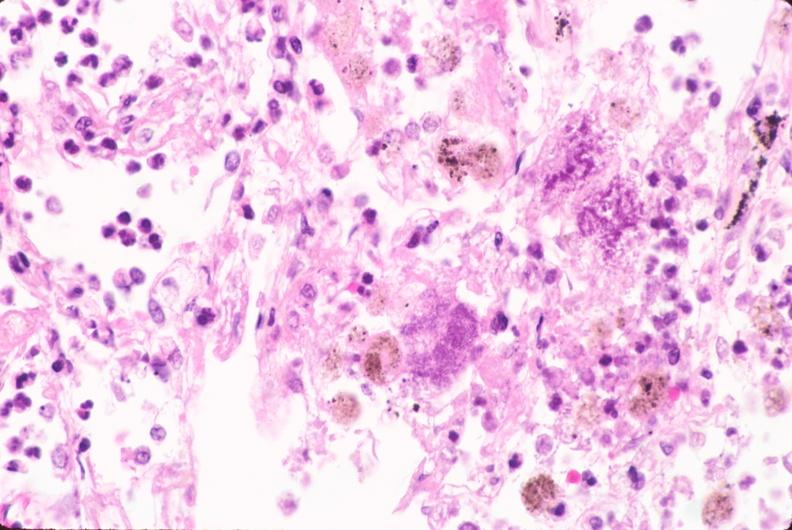where is this?
Answer the question using a single word or phrase. Lung 